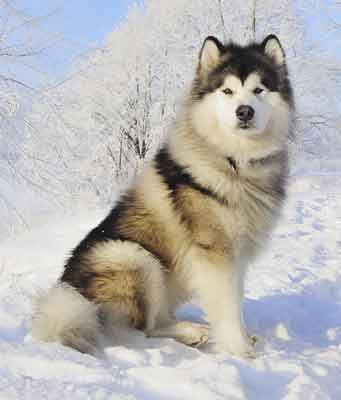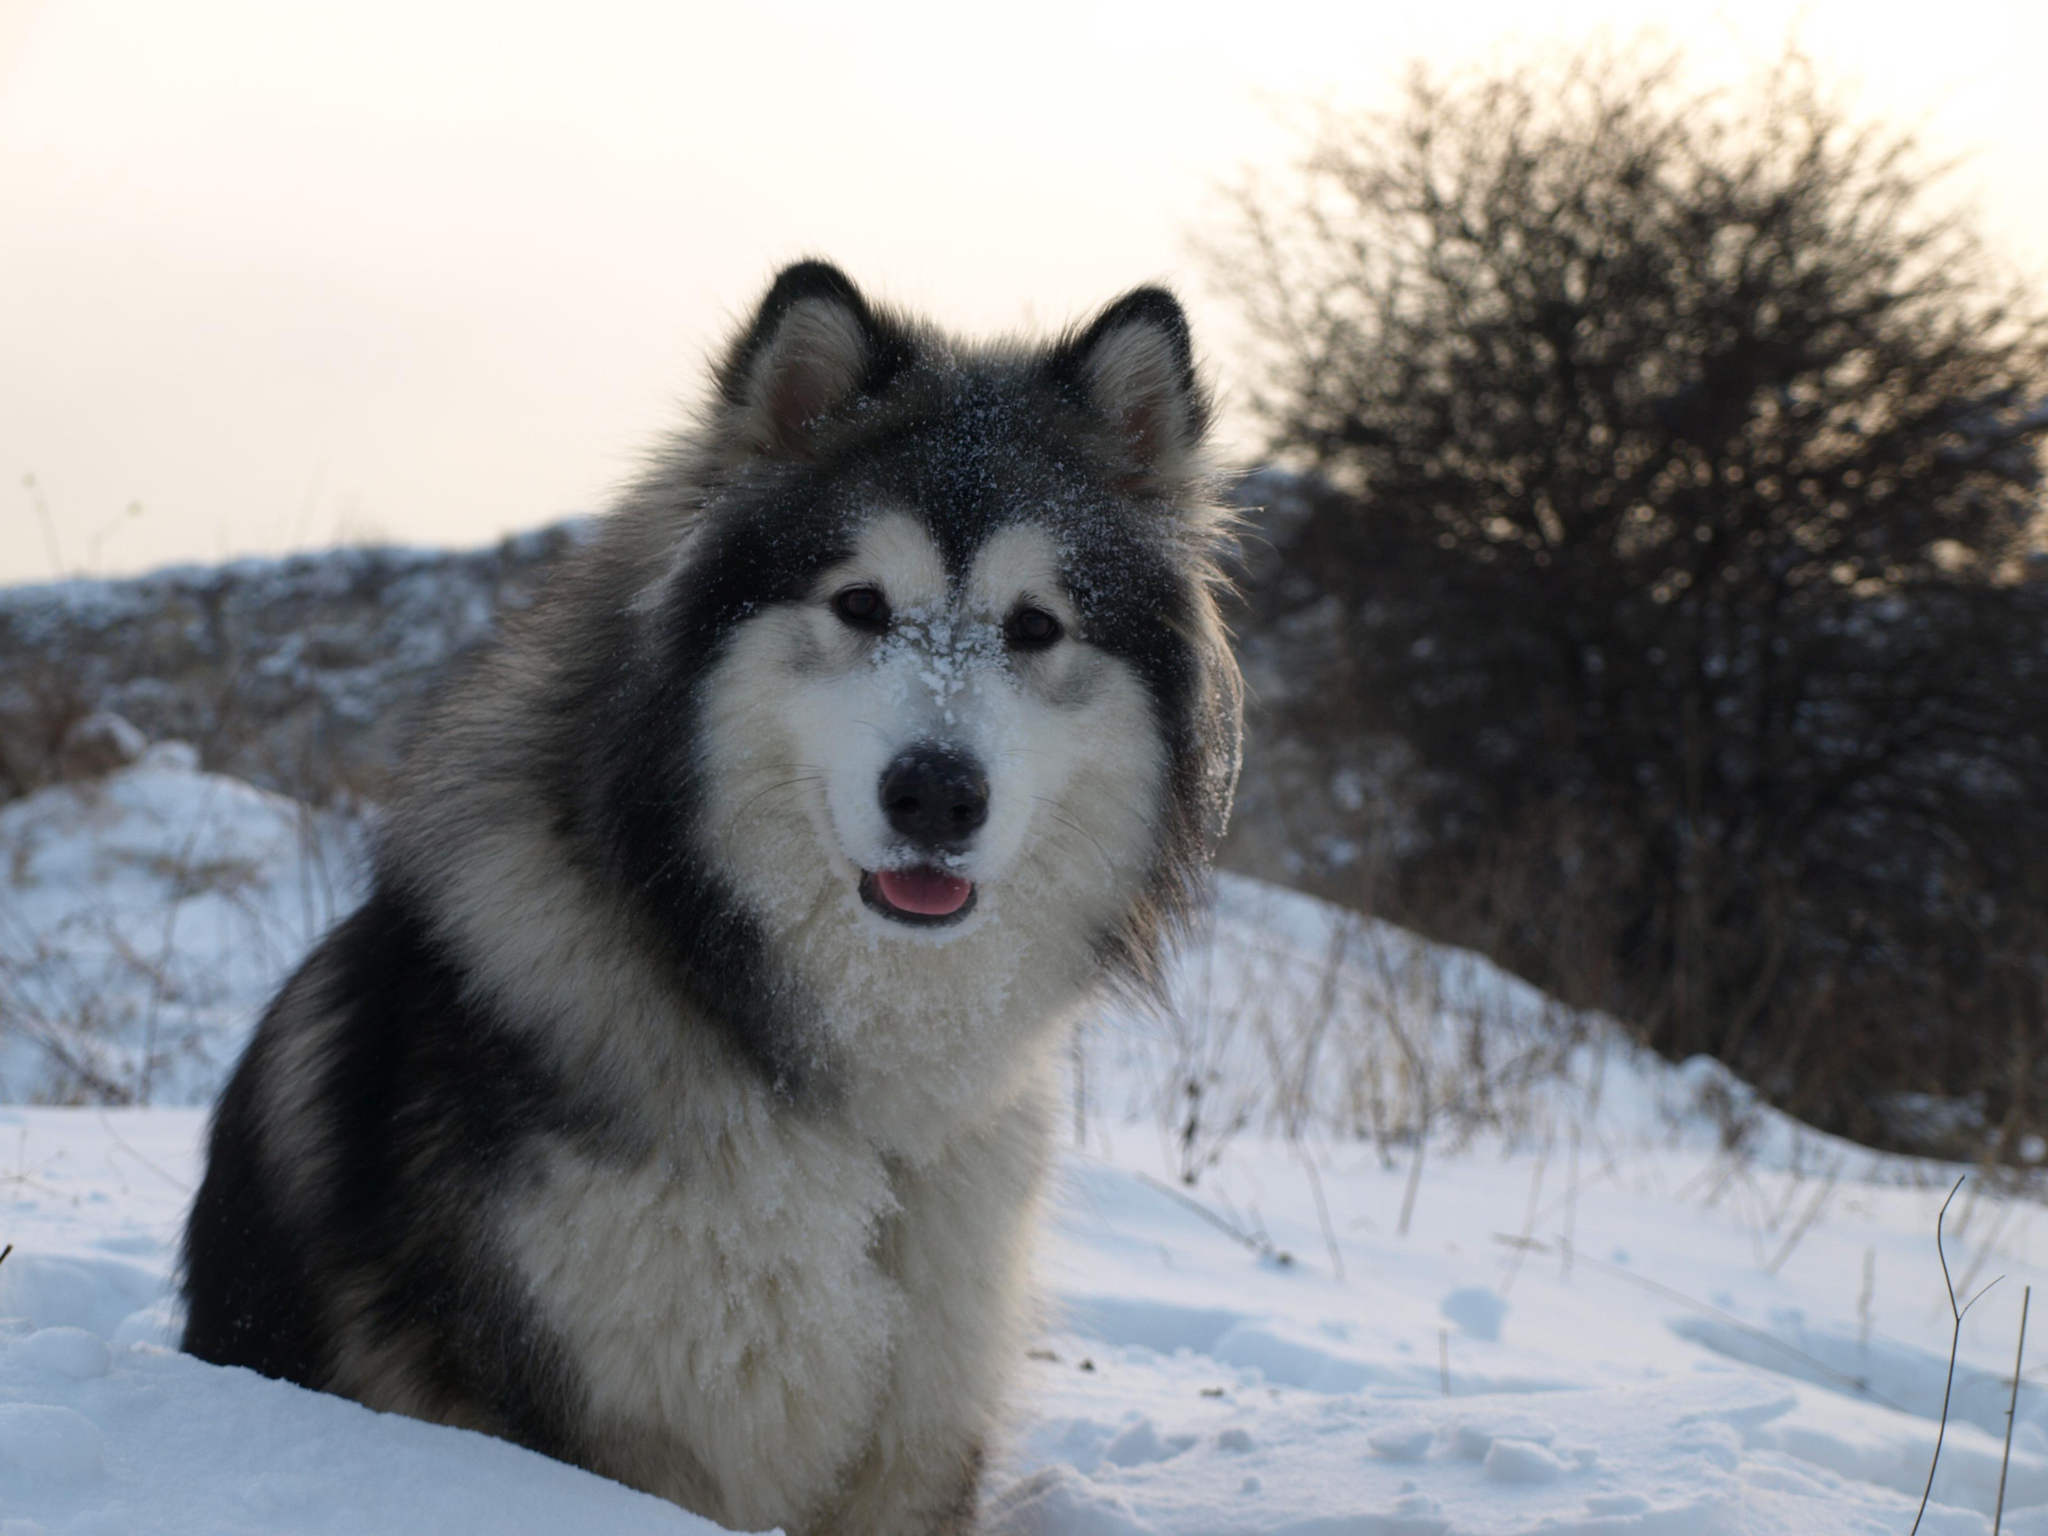The first image is the image on the left, the second image is the image on the right. Considering the images on both sides, is "There are three dogs." valid? Answer yes or no. No. The first image is the image on the left, the second image is the image on the right. Considering the images on both sides, is "The left and right image contains the same number of dogs." valid? Answer yes or no. Yes. 